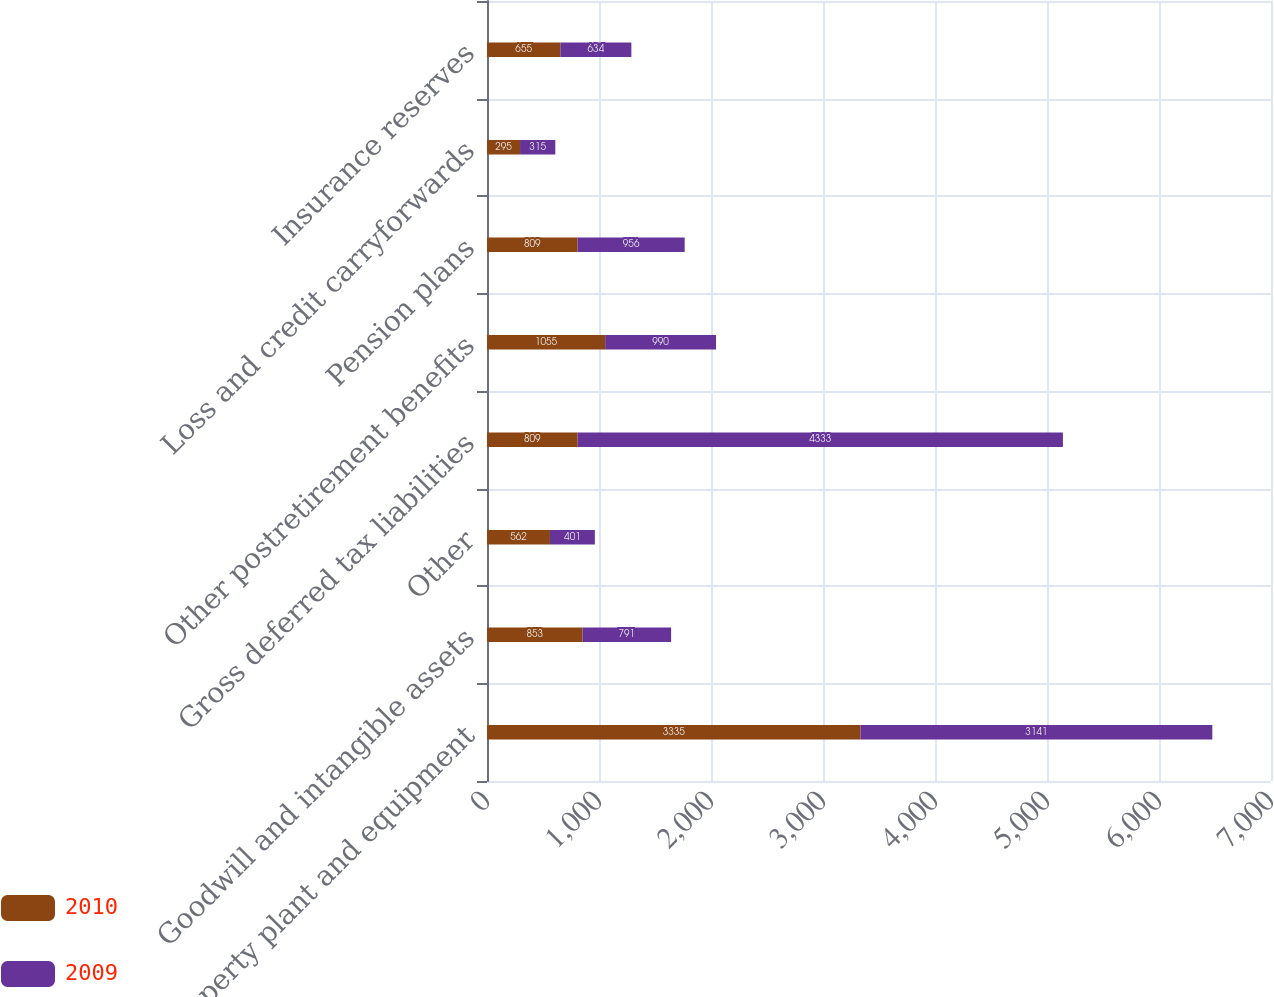Convert chart to OTSL. <chart><loc_0><loc_0><loc_500><loc_500><stacked_bar_chart><ecel><fcel>Property plant and equipment<fcel>Goodwill and intangible assets<fcel>Other<fcel>Gross deferred tax liabilities<fcel>Other postretirement benefits<fcel>Pension plans<fcel>Loss and credit carryforwards<fcel>Insurance reserves<nl><fcel>2010<fcel>3335<fcel>853<fcel>562<fcel>809<fcel>1055<fcel>809<fcel>295<fcel>655<nl><fcel>2009<fcel>3141<fcel>791<fcel>401<fcel>4333<fcel>990<fcel>956<fcel>315<fcel>634<nl></chart> 